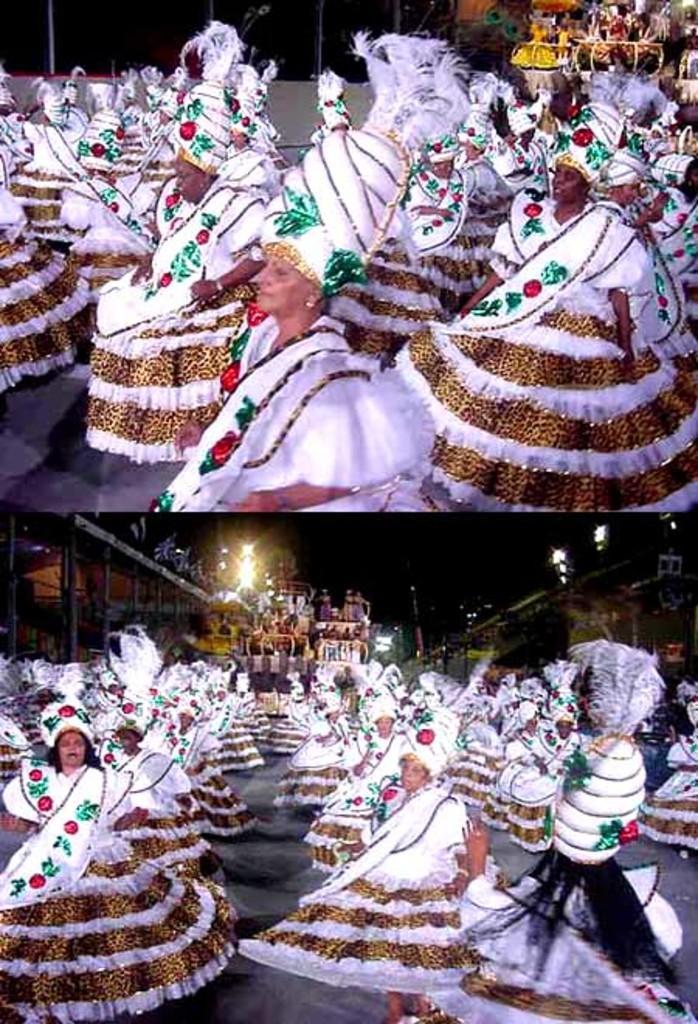Please provide a concise description of this image. This is an image with collage in which we can see a group of people wearing the costumes standing on the ground. We can also see some lights, poles and some buildings. 